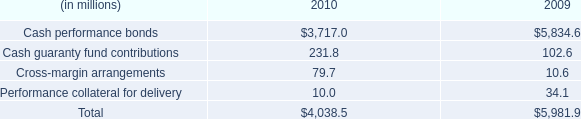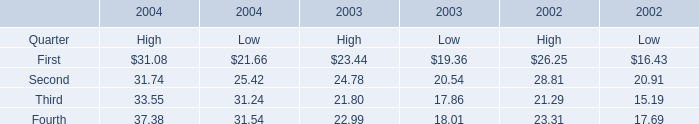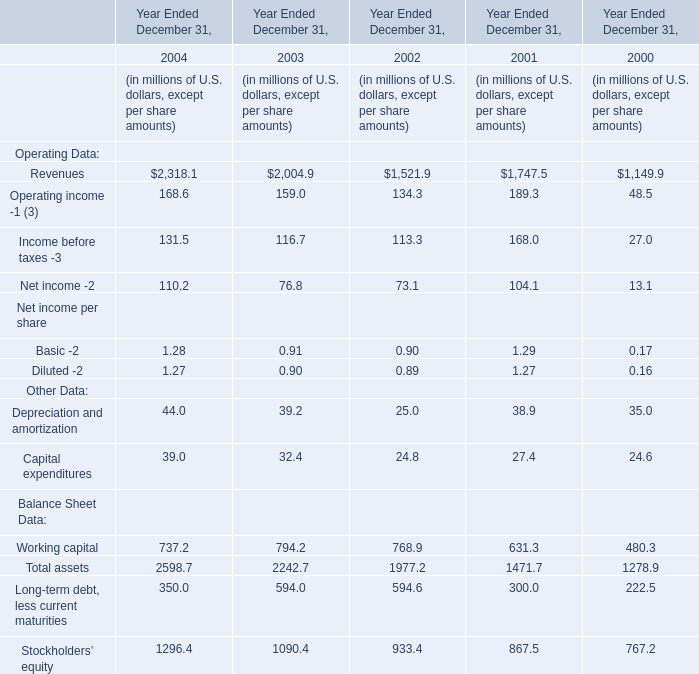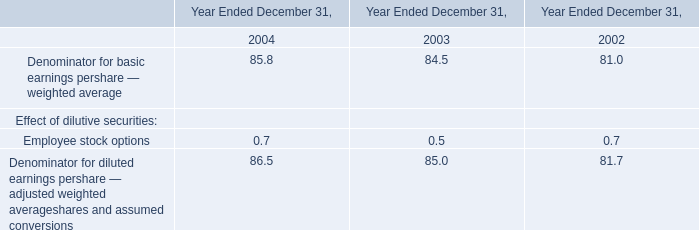In which year is the Total assets the most? 
Answer: 2004. 